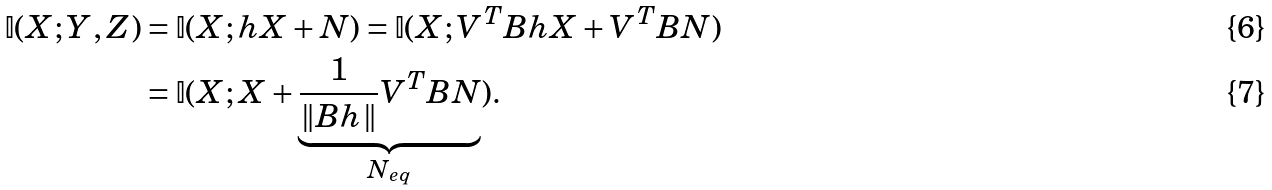<formula> <loc_0><loc_0><loc_500><loc_500>\mathbb { I } ( X ; Y , Z ) & = \mathbb { I } ( X ; h X + N ) = \mathbb { I } ( X ; V ^ { T } B h X + V ^ { T } B N ) \\ & = \mathbb { I } ( X ; X + \underbrace { \frac { 1 } { \| B h \| } V ^ { T } B N } _ { N _ { e q } } ) .</formula> 